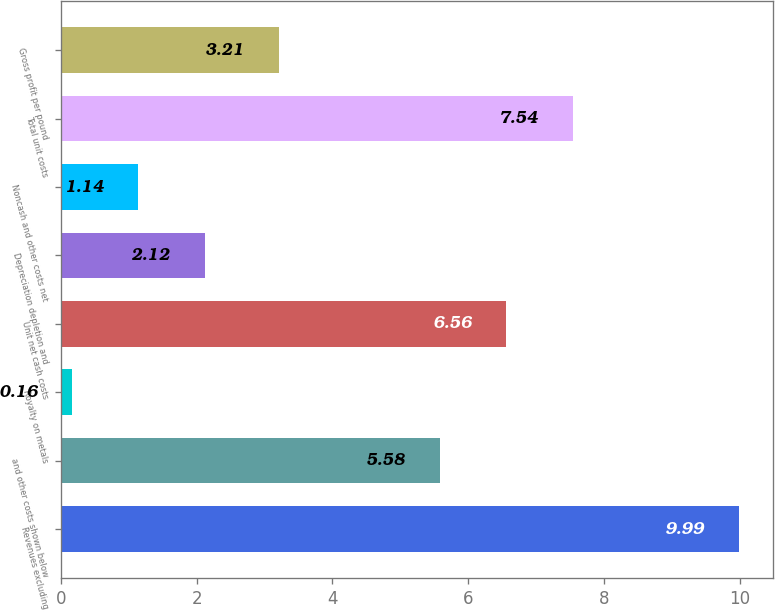Convert chart to OTSL. <chart><loc_0><loc_0><loc_500><loc_500><bar_chart><fcel>Revenues excluding<fcel>and other costs shown below<fcel>Royalty on metals<fcel>Unit net cash costs<fcel>Depreciation depletion and<fcel>Noncash and other costs net<fcel>Total unit costs<fcel>Gross profit per pound<nl><fcel>9.99<fcel>5.58<fcel>0.16<fcel>6.56<fcel>2.12<fcel>1.14<fcel>7.54<fcel>3.21<nl></chart> 